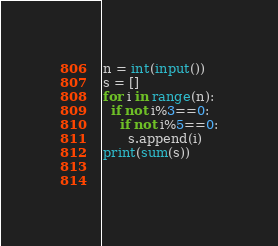<code> <loc_0><loc_0><loc_500><loc_500><_Python_>n = int(input())
s = []
for i in range(n):
  if not i%3==0:
    if not i%5==0:
      s.append(i)
print(sum(s))
    
    </code> 